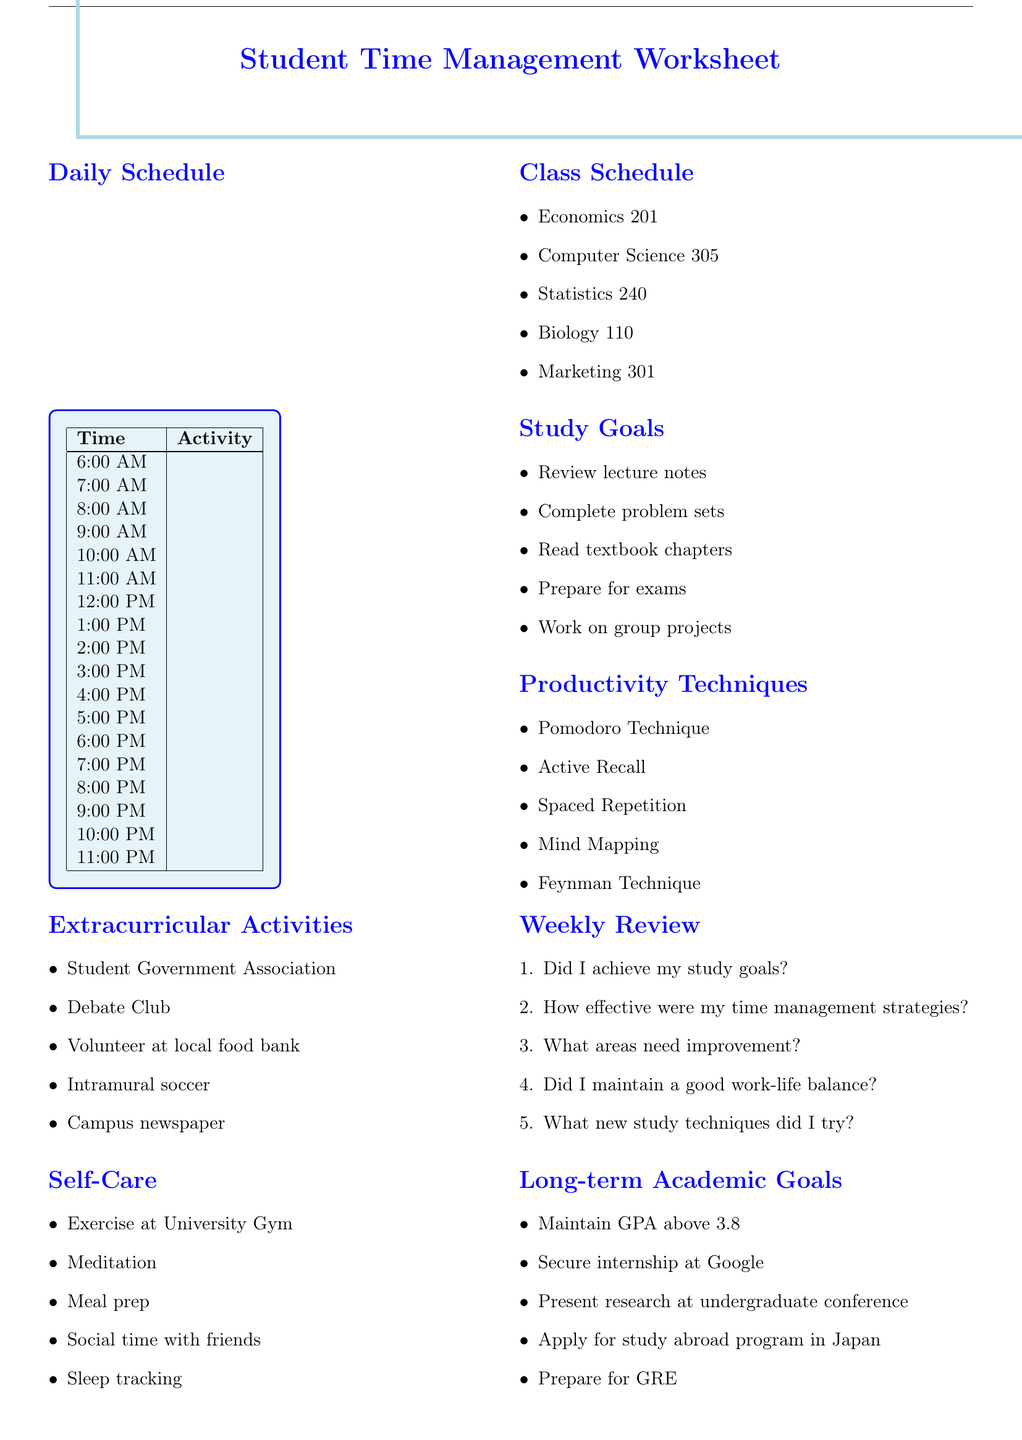What is the title of the document? The title is indicated at the beginning of the document.
Answer: Student Time Management Worksheet How many time slots are included in the Daily Schedule section? The time slots are listed in a table format, from 6:00 AM to 11:00 PM.
Answer: 18 What is one of the productivity techniques mentioned? The document lists specific methods under the Productivity Techniques section.
Answer: Pomodoro Technique Which class is listed first in the Class Schedule? The classes are presented in a bullet point format under the Class Schedule section.
Answer: Economics 201 What is one self-care task mentioned in the document? The document provides specific tasks under the Self-Care section.
Answer: Exercise at University Gym How many weekly review questions are provided? The Weekly Review section includes a numbered list of specific questions.
Answer: 5 What is the goal related to GPA in the Long-term Academic Goals section? The Long-term Academic Goals section lists specific academic objectives.
Answer: Maintain GPA above 3.8 Which extracurricular activity involves volunteering? The document specifies different activities under the Extracurricular Activities section.
Answer: Volunteer at local food bank What technique is referenced under the Study Goals section that involves solving problems? The Study Goals section lists specific objectives meant for academic progress.
Answer: Complete problem sets 